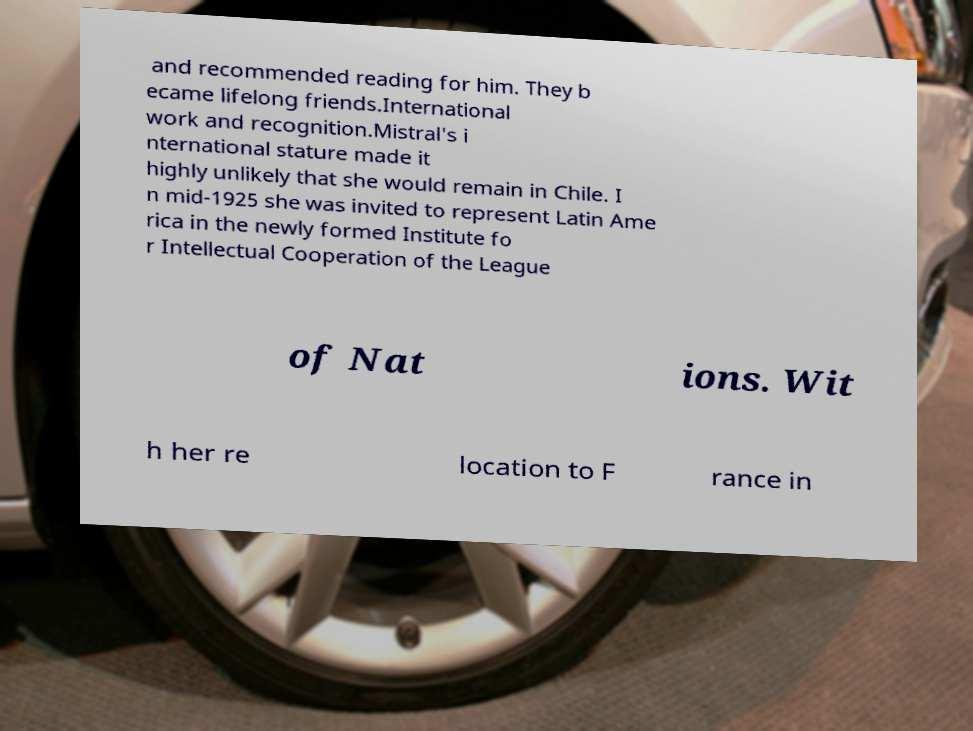Please read and relay the text visible in this image. What does it say? and recommended reading for him. They b ecame lifelong friends.International work and recognition.Mistral's i nternational stature made it highly unlikely that she would remain in Chile. I n mid-1925 she was invited to represent Latin Ame rica in the newly formed Institute fo r Intellectual Cooperation of the League of Nat ions. Wit h her re location to F rance in 